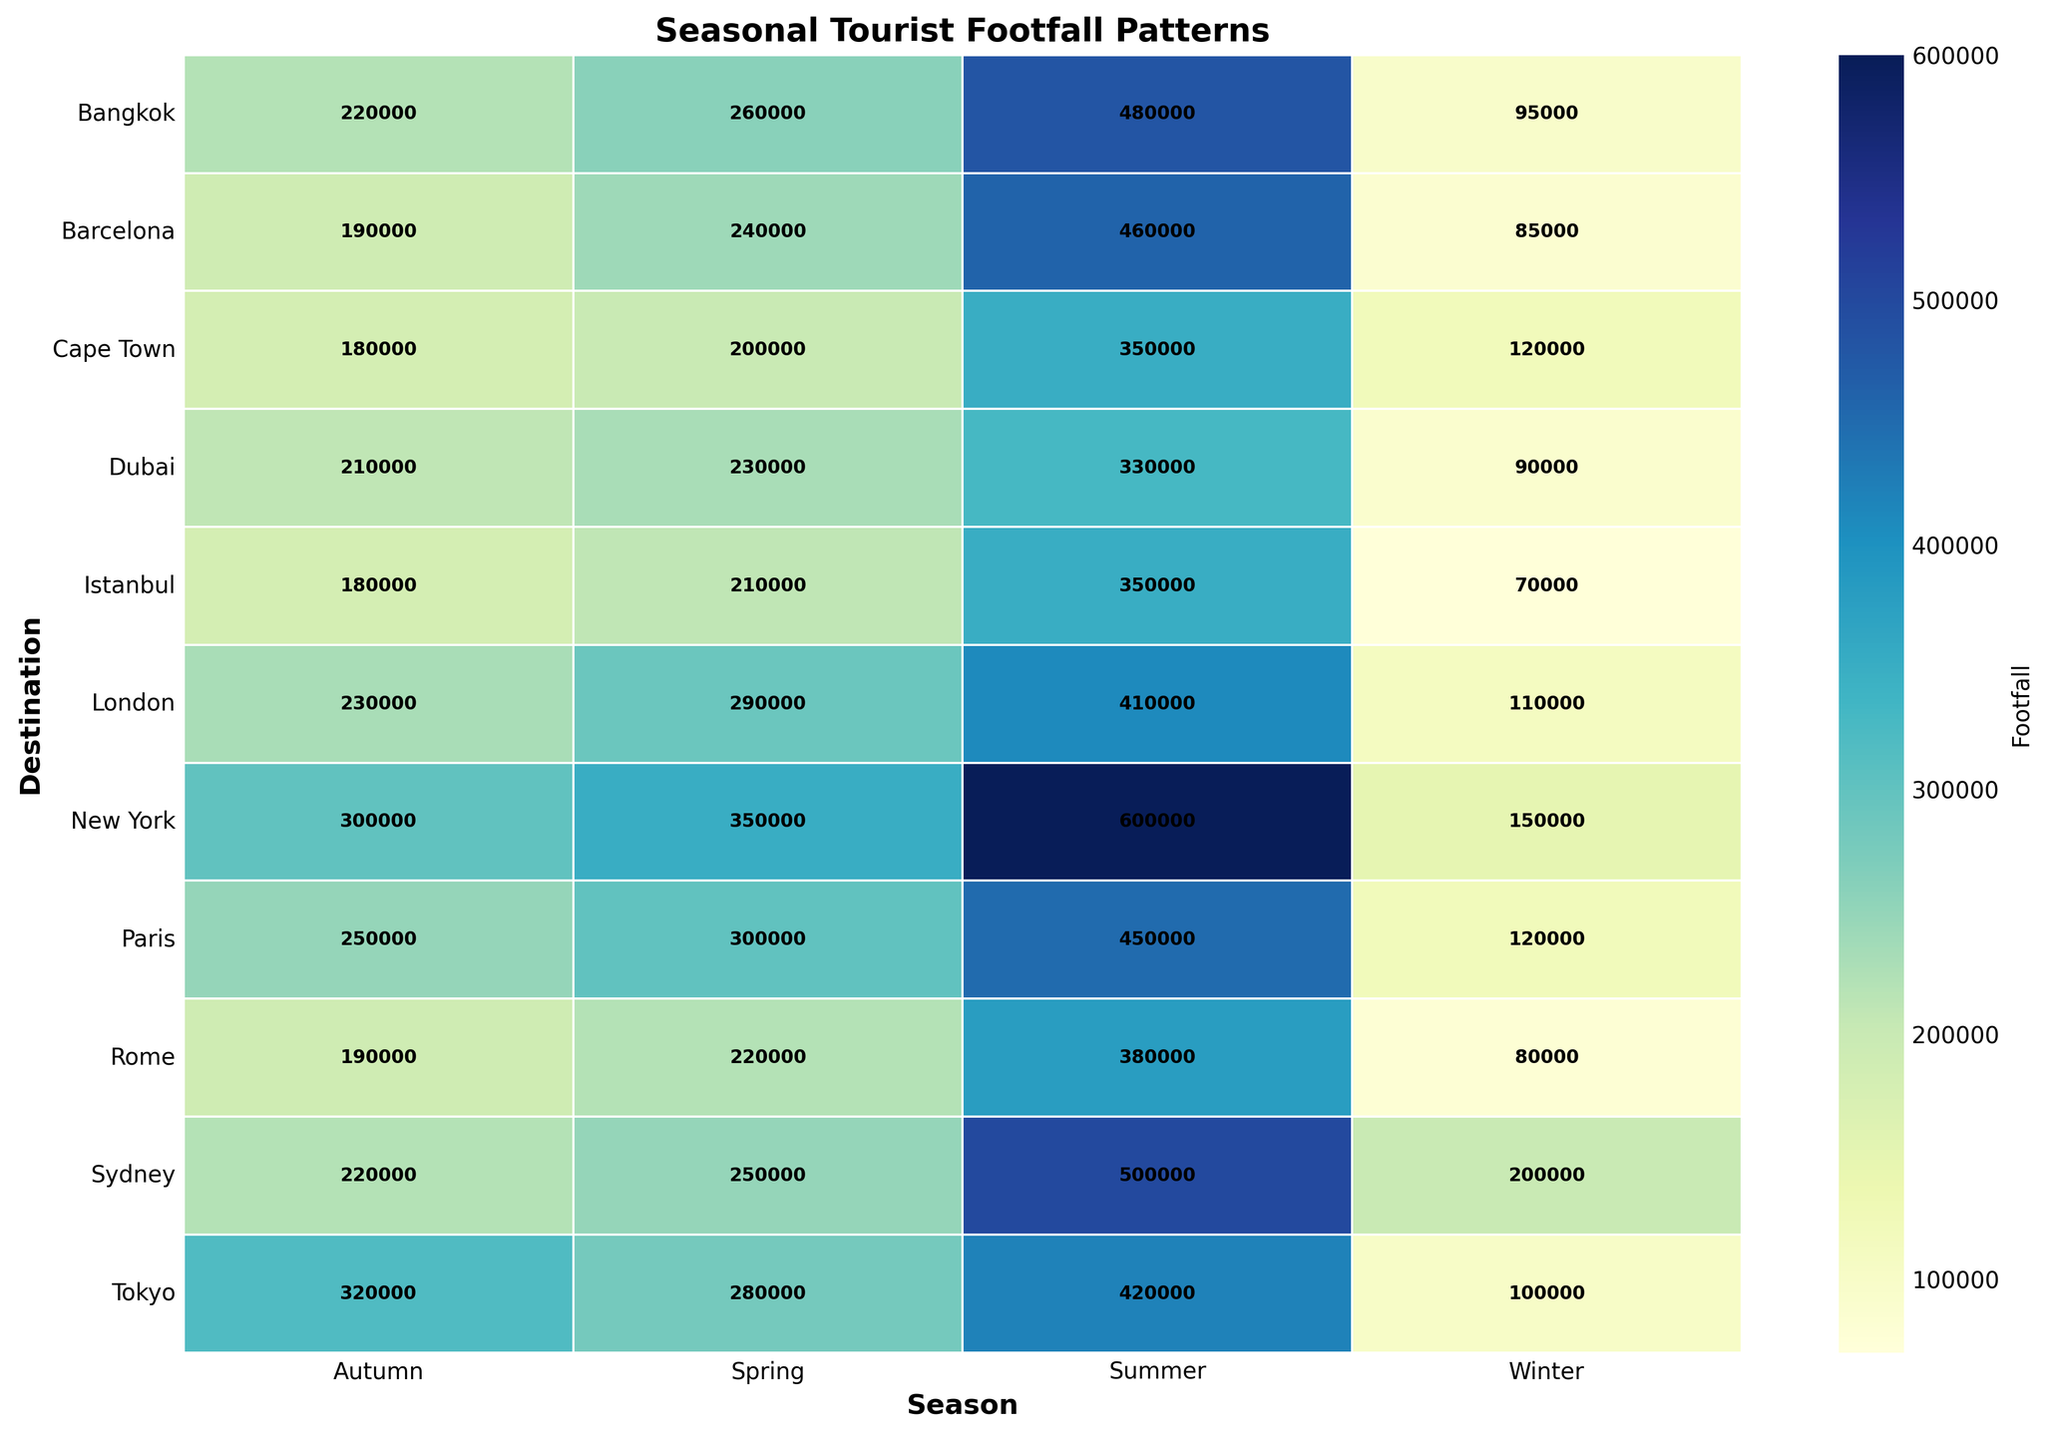What destination has the highest footfall in Summer? To find the destination with the highest footfall in Summer, look at the Summer column and identify the highest value. The highest number is 600,000 for New York.
Answer: New York Which season has the highest overall footfall for Dubai and Sydney combined? For Dubai: Winter (90,000), Spring (230,000), Summer (330,000), Autumn (210,000). Sum these values: 90,000 + 230,000 + 330,000 + 210,000 = 860,000. For Sydney: Winter (200,000), Spring (250,000), Summer (500,000), Autumn (220,000). Sum these values: 200,000 + 250,000 + 500,000 + 220,000 = 1,170,000. Summer has the highest combined total: 330,000 (Dubai) + 500,000 (Sydney) = 830,000
Answer: Summer What season has the lowest footfall for Paris? Look at the footfall values for each season in Paris: Winter (120,000), Spring (300,000), Summer (450,000), Autumn (250,000). The lowest value is 120,000 in Winter.
Answer: Winter Is the tourist footfall in Winter higher in New York or Paris? Compare the Winter footfall between New York (150,000) and Paris (120,000). Since 150,000 is greater than 120,000, New York has a higher footfall in Winter.
Answer: New York What is the average footfall for Tokyo across all seasons? Sum the footfalls for all four seasons in Tokyo (100,000 + 280,000 + 420,000 + 320,000) and then divide by 4: (100,000 + 280,000 + 420,000 + 320,000) / 4 = 1,120,000 / 4 = 280,000.
Answer: 280,000 Which destination has the most consistent footfall across all seasons (least variation in footfall)? Calculate the range (difference between the highest and lowest footfall) for each destination:
Paris: 450,000 - 120,000 = 330,000;
Rome: 380,000 - 80,000 = 300,000;
New York: 600,000 - 150,000 = 450,000;
Tokyo: 420,000 - 100,000 = 320,000;
Sydney: 500,000 - 200,000 = 300,000;
London: 410,000 - 110,000 = 300,000;
Dubai: 330,000 - 90,000 = 240,000;
Istanbul: 350,000 - 70,000 = 280,000;
Bangkok: 480,000 - 95,000 = 385,000;
Cape Town: 350,000 - 120,000 = 230,000;
Barcelona: 460,000 - 85,000 = 375,000. The least variation is seen in Cape Town with a range of 230,000.
Answer: Cape Town How much higher is the Spring footfall in London compared to the Winter footfall for the same city? Subtract the Winter footfall in London (110,000) from the Spring footfall (290,000): 290,000 - 110,000 = 180,000.
Answer: 180,000 What seasons have the same or nearly similar footfall values for any destination? Look for similar values in different seasons for any destination:
Paris has comparisons like Spring (300,000) and Autumn (250,000);
Rome has comparisons like Winter (80,000) and Autumn (190,000);
New York has comparisons like Autumn (300,000) and Spring (350,000);
Tokyo has comparisons like Spring (280,000) and Autumn (320,000);
Sydney has comparisons like Winter (200,000) and Autumn (220,000);
London has comparisons like Spring (290,000) and Autumn (230,000);
Dubai has comparisons like Spring (230,000) and Autumn (210,000);
Istanbul has comparisons like Spring (210,000) and Autumn (180,000);
Bangkok has comparisons like Spring (260,000) and Autumn (220,000);
Cape Town has comparisons like Spring (200,000) and Autumn (180,000);
Barcelona has comparisons like Spring (240,000) and Autumn (190,000).
Answer: Sydney in Winter and Autumn, with values of 200,000 and 220,000 respectively 